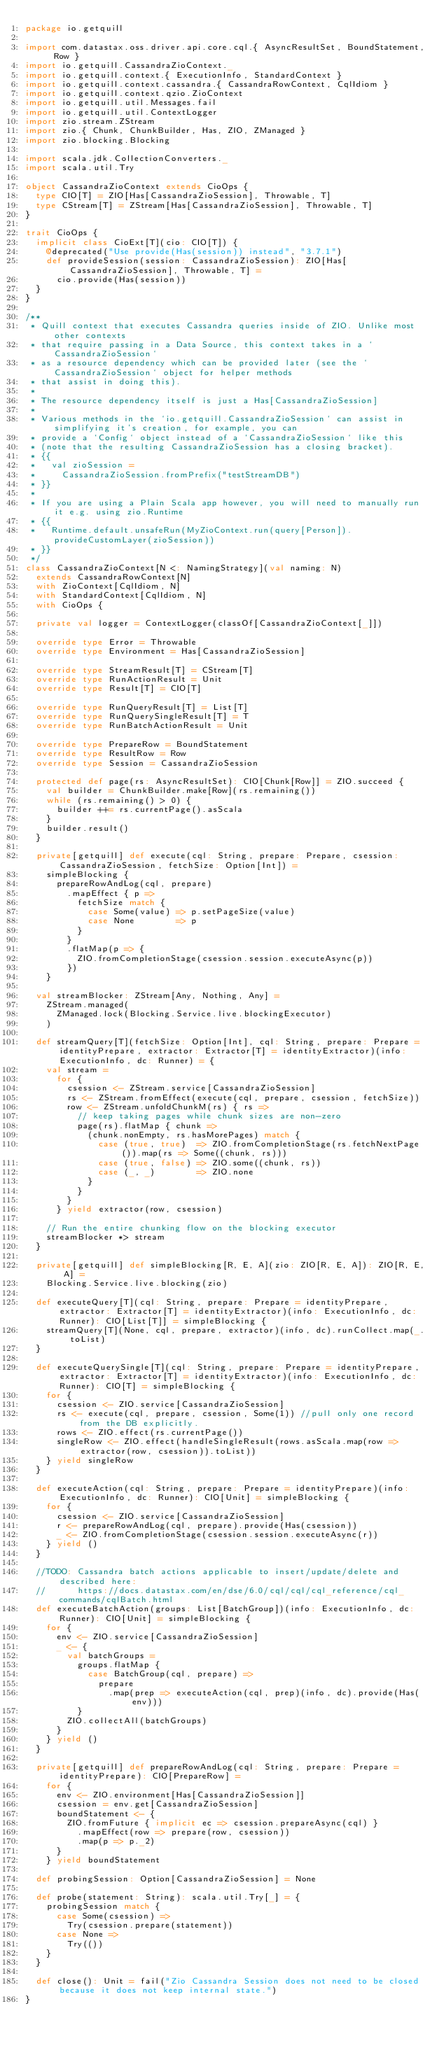Convert code to text. <code><loc_0><loc_0><loc_500><loc_500><_Scala_>package io.getquill

import com.datastax.oss.driver.api.core.cql.{ AsyncResultSet, BoundStatement, Row }
import io.getquill.CassandraZioContext._
import io.getquill.context.{ ExecutionInfo, StandardContext }
import io.getquill.context.cassandra.{ CassandraRowContext, CqlIdiom }
import io.getquill.context.qzio.ZioContext
import io.getquill.util.Messages.fail
import io.getquill.util.ContextLogger
import zio.stream.ZStream
import zio.{ Chunk, ChunkBuilder, Has, ZIO, ZManaged }
import zio.blocking.Blocking

import scala.jdk.CollectionConverters._
import scala.util.Try

object CassandraZioContext extends CioOps {
  type CIO[T] = ZIO[Has[CassandraZioSession], Throwable, T]
  type CStream[T] = ZStream[Has[CassandraZioSession], Throwable, T]
}

trait CioOps {
  implicit class CioExt[T](cio: CIO[T]) {
    @deprecated("Use provide(Has(session)) instead", "3.7.1")
    def provideSession(session: CassandraZioSession): ZIO[Has[CassandraZioSession], Throwable, T] =
      cio.provide(Has(session))
  }
}

/**
 * Quill context that executes Cassandra queries inside of ZIO. Unlike most other contexts
 * that require passing in a Data Source, this context takes in a `CassandraZioSession`
 * as a resource dependency which can be provided later (see the `CassandraZioSession` object for helper methods
 * that assist in doing this).
 *
 * The resource dependency itself is just a Has[CassandraZioSession]
 *
 * Various methods in the `io.getquill.CassandraZioSession` can assist in simplifying it's creation, for example, you can
 * provide a `Config` object instead of a `CassandraZioSession` like this
 * (note that the resulting CassandraZioSession has a closing bracket).
 * {{
 *   val zioSession =
 *     CassandraZioSession.fromPrefix("testStreamDB")
 * }}
 *
 * If you are using a Plain Scala app however, you will need to manually run it e.g. using zio.Runtime
 * {{
 *   Runtime.default.unsafeRun(MyZioContext.run(query[Person]).provideCustomLayer(zioSession))
 * }}
 */
class CassandraZioContext[N <: NamingStrategy](val naming: N)
  extends CassandraRowContext[N]
  with ZioContext[CqlIdiom, N]
  with StandardContext[CqlIdiom, N]
  with CioOps {

  private val logger = ContextLogger(classOf[CassandraZioContext[_]])

  override type Error = Throwable
  override type Environment = Has[CassandraZioSession]

  override type StreamResult[T] = CStream[T]
  override type RunActionResult = Unit
  override type Result[T] = CIO[T]

  override type RunQueryResult[T] = List[T]
  override type RunQuerySingleResult[T] = T
  override type RunBatchActionResult = Unit

  override type PrepareRow = BoundStatement
  override type ResultRow = Row
  override type Session = CassandraZioSession

  protected def page(rs: AsyncResultSet): CIO[Chunk[Row]] = ZIO.succeed {
    val builder = ChunkBuilder.make[Row](rs.remaining())
    while (rs.remaining() > 0) {
      builder ++= rs.currentPage().asScala
    }
    builder.result()
  }

  private[getquill] def execute(cql: String, prepare: Prepare, csession: CassandraZioSession, fetchSize: Option[Int]) =
    simpleBlocking {
      prepareRowAndLog(cql, prepare)
        .mapEffect { p =>
          fetchSize match {
            case Some(value) => p.setPageSize(value)
            case None        => p
          }
        }
        .flatMap(p => {
          ZIO.fromCompletionStage(csession.session.executeAsync(p))
        })
    }

  val streamBlocker: ZStream[Any, Nothing, Any] =
    ZStream.managed(
      ZManaged.lock(Blocking.Service.live.blockingExecutor)
    )

  def streamQuery[T](fetchSize: Option[Int], cql: String, prepare: Prepare = identityPrepare, extractor: Extractor[T] = identityExtractor)(info: ExecutionInfo, dc: Runner) = {
    val stream =
      for {
        csession <- ZStream.service[CassandraZioSession]
        rs <- ZStream.fromEffect(execute(cql, prepare, csession, fetchSize))
        row <- ZStream.unfoldChunkM(rs) { rs =>
          // keep taking pages while chunk sizes are non-zero
          page(rs).flatMap { chunk =>
            (chunk.nonEmpty, rs.hasMorePages) match {
              case (true, true)  => ZIO.fromCompletionStage(rs.fetchNextPage()).map(rs => Some((chunk, rs)))
              case (true, false) => ZIO.some((chunk, rs))
              case (_, _)        => ZIO.none
            }
          }
        }
      } yield extractor(row, csession)

    // Run the entire chunking flow on the blocking executor
    streamBlocker *> stream
  }

  private[getquill] def simpleBlocking[R, E, A](zio: ZIO[R, E, A]): ZIO[R, E, A] =
    Blocking.Service.live.blocking(zio)

  def executeQuery[T](cql: String, prepare: Prepare = identityPrepare, extractor: Extractor[T] = identityExtractor)(info: ExecutionInfo, dc: Runner): CIO[List[T]] = simpleBlocking {
    streamQuery[T](None, cql, prepare, extractor)(info, dc).runCollect.map(_.toList)
  }

  def executeQuerySingle[T](cql: String, prepare: Prepare = identityPrepare, extractor: Extractor[T] = identityExtractor)(info: ExecutionInfo, dc: Runner): CIO[T] = simpleBlocking {
    for {
      csession <- ZIO.service[CassandraZioSession]
      rs <- execute(cql, prepare, csession, Some(1)) //pull only one record from the DB explicitly.
      rows <- ZIO.effect(rs.currentPage())
      singleRow <- ZIO.effect(handleSingleResult(rows.asScala.map(row => extractor(row, csession)).toList))
    } yield singleRow
  }

  def executeAction(cql: String, prepare: Prepare = identityPrepare)(info: ExecutionInfo, dc: Runner): CIO[Unit] = simpleBlocking {
    for {
      csession <- ZIO.service[CassandraZioSession]
      r <- prepareRowAndLog(cql, prepare).provide(Has(csession))
      _ <- ZIO.fromCompletionStage(csession.session.executeAsync(r))
    } yield ()
  }

  //TODO: Cassandra batch actions applicable to insert/update/delete and  described here:
  //      https://docs.datastax.com/en/dse/6.0/cql/cql/cql_reference/cql_commands/cqlBatch.html
  def executeBatchAction(groups: List[BatchGroup])(info: ExecutionInfo, dc: Runner): CIO[Unit] = simpleBlocking {
    for {
      env <- ZIO.service[CassandraZioSession]
      _ <- {
        val batchGroups =
          groups.flatMap {
            case BatchGroup(cql, prepare) =>
              prepare
                .map(prep => executeAction(cql, prep)(info, dc).provide(Has(env)))
          }
        ZIO.collectAll(batchGroups)
      }
    } yield ()
  }

  private[getquill] def prepareRowAndLog(cql: String, prepare: Prepare = identityPrepare): CIO[PrepareRow] =
    for {
      env <- ZIO.environment[Has[CassandraZioSession]]
      csession = env.get[CassandraZioSession]
      boundStatement <- {
        ZIO.fromFuture { implicit ec => csession.prepareAsync(cql) }
          .mapEffect(row => prepare(row, csession))
          .map(p => p._2)
      }
    } yield boundStatement

  def probingSession: Option[CassandraZioSession] = None

  def probe(statement: String): scala.util.Try[_] = {
    probingSession match {
      case Some(csession) =>
        Try(csession.prepare(statement))
      case None =>
        Try(())
    }
  }

  def close(): Unit = fail("Zio Cassandra Session does not need to be closed because it does not keep internal state.")
}
</code> 